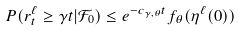<formula> <loc_0><loc_0><loc_500><loc_500>P ( r ^ { \ell } _ { t } \geq \gamma t | \mathcal { F } _ { 0 } ) \leq e ^ { - c _ { \gamma , \theta } t } f _ { \theta } ( \eta ^ { \ell } ( 0 ) )</formula> 